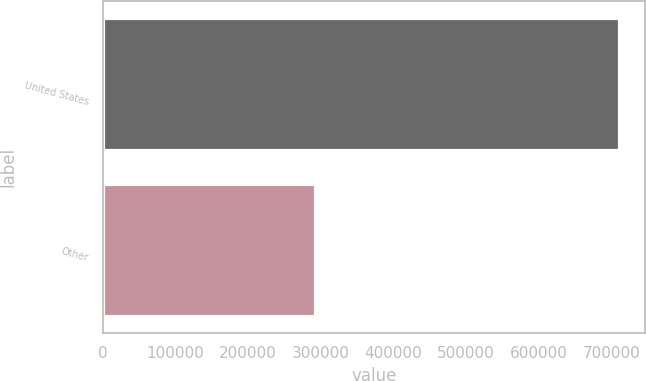Convert chart to OTSL. <chart><loc_0><loc_0><loc_500><loc_500><bar_chart><fcel>United States<fcel>Other<nl><fcel>710614<fcel>291731<nl></chart> 